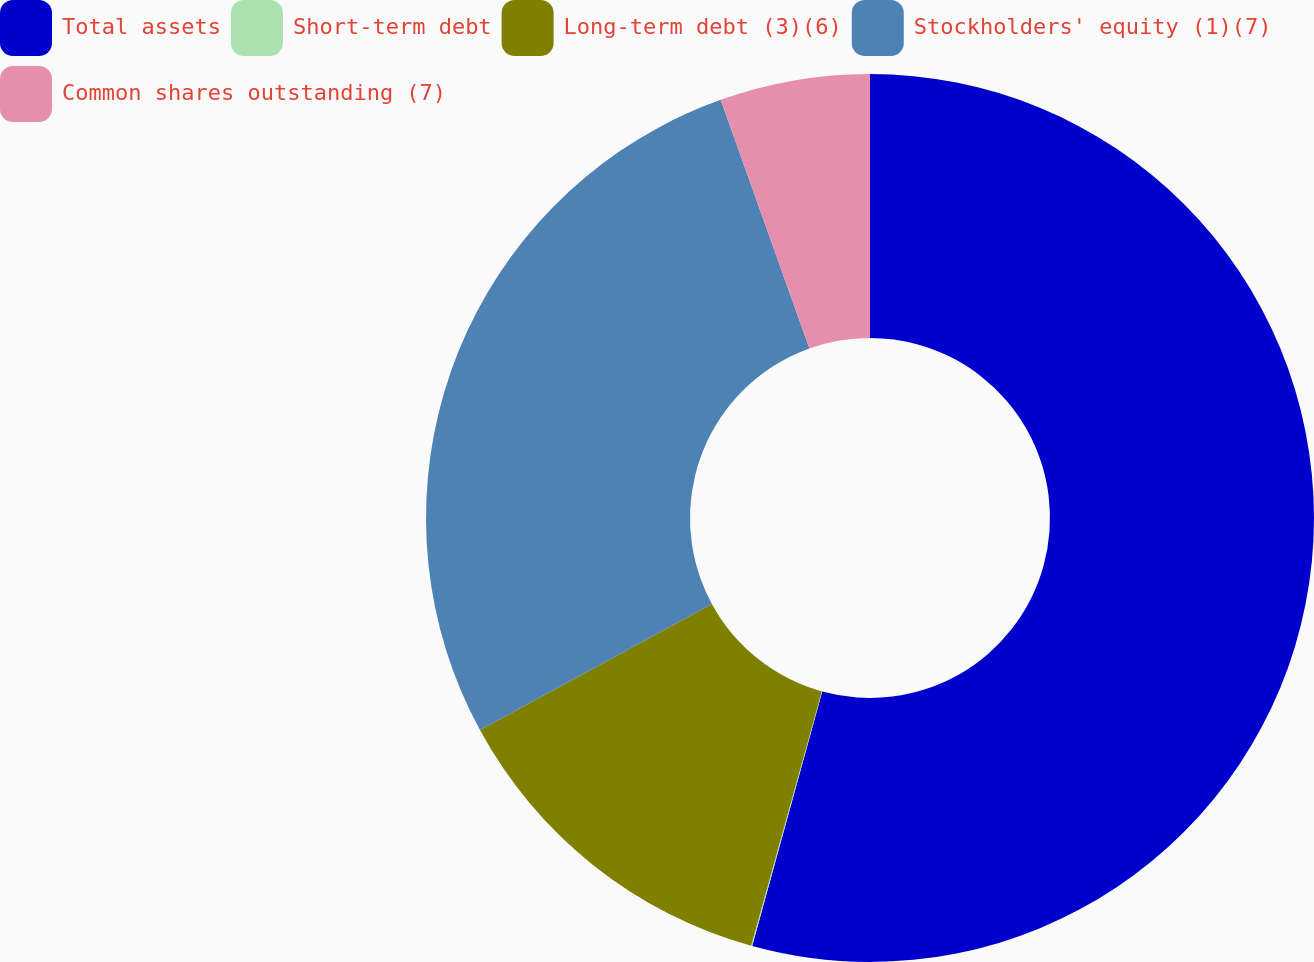Convert chart to OTSL. <chart><loc_0><loc_0><loc_500><loc_500><pie_chart><fcel>Total assets<fcel>Short-term debt<fcel>Long-term debt (3)(6)<fcel>Stockholders' equity (1)(7)<fcel>Common shares outstanding (7)<nl><fcel>54.28%<fcel>0.04%<fcel>12.76%<fcel>27.47%<fcel>5.46%<nl></chart> 